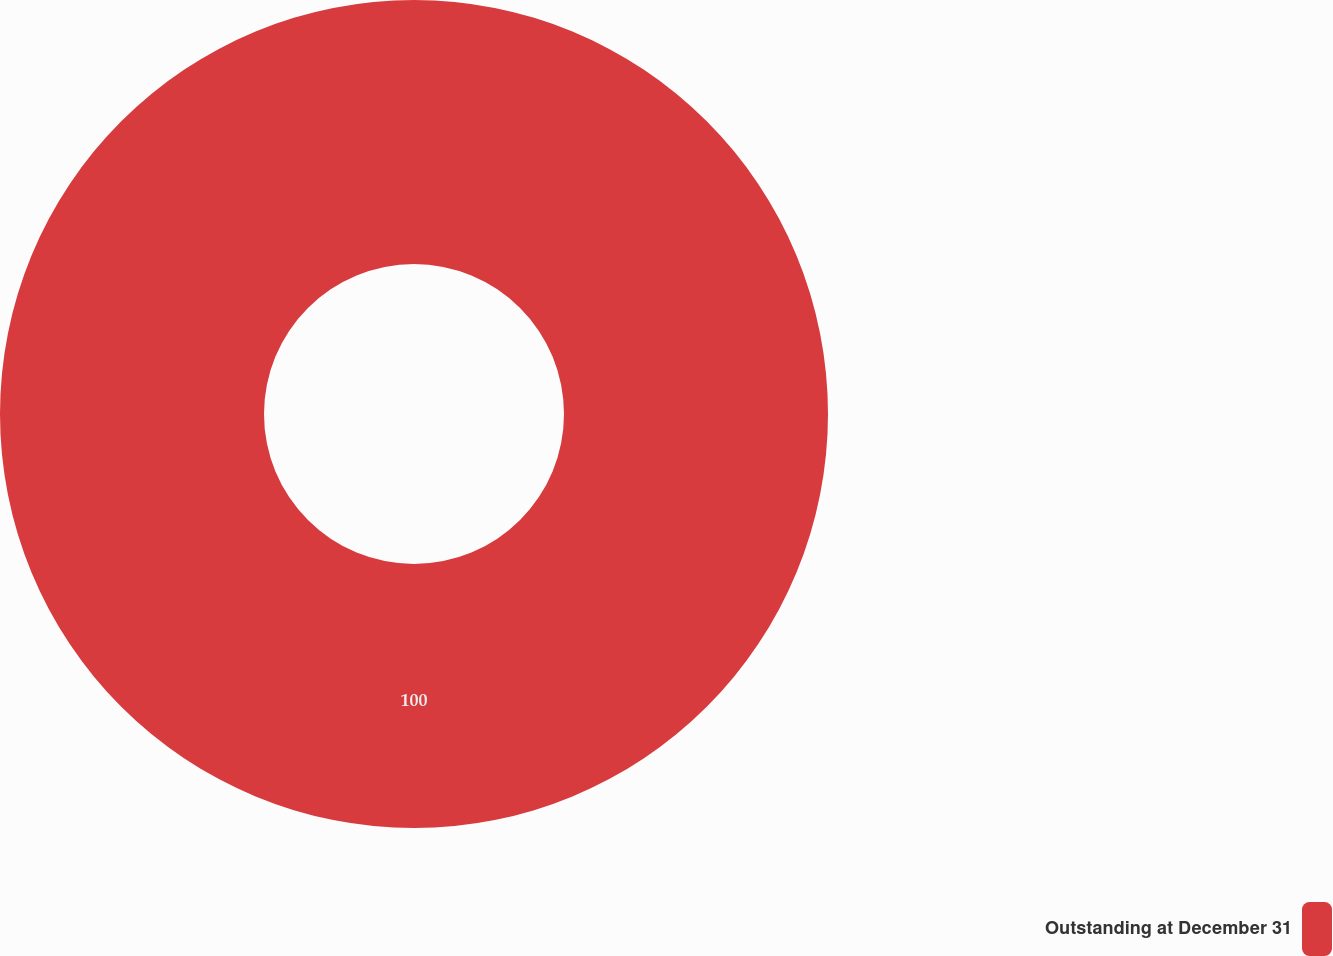Convert chart. <chart><loc_0><loc_0><loc_500><loc_500><pie_chart><fcel>Outstanding at December 31<nl><fcel>100.0%<nl></chart> 